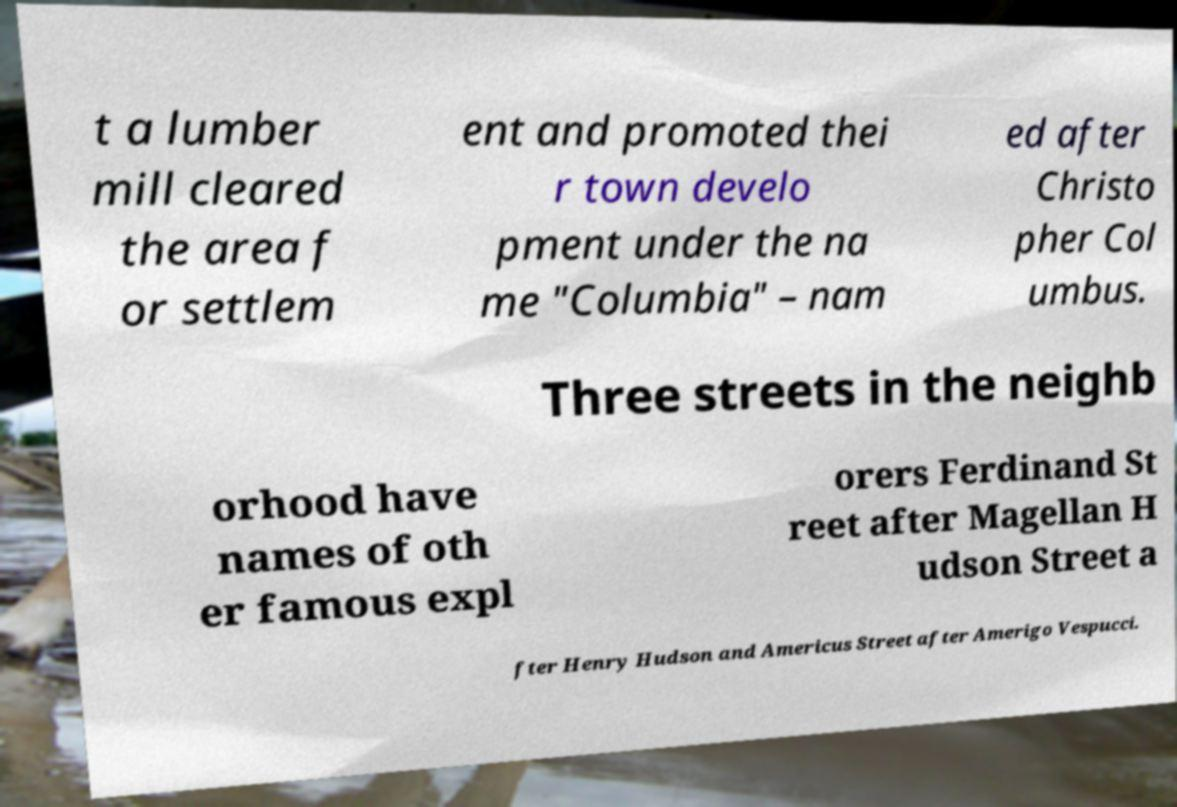Please read and relay the text visible in this image. What does it say? t a lumber mill cleared the area f or settlem ent and promoted thei r town develo pment under the na me "Columbia" – nam ed after Christo pher Col umbus. Three streets in the neighb orhood have names of oth er famous expl orers Ferdinand St reet after Magellan H udson Street a fter Henry Hudson and Americus Street after Amerigo Vespucci. 